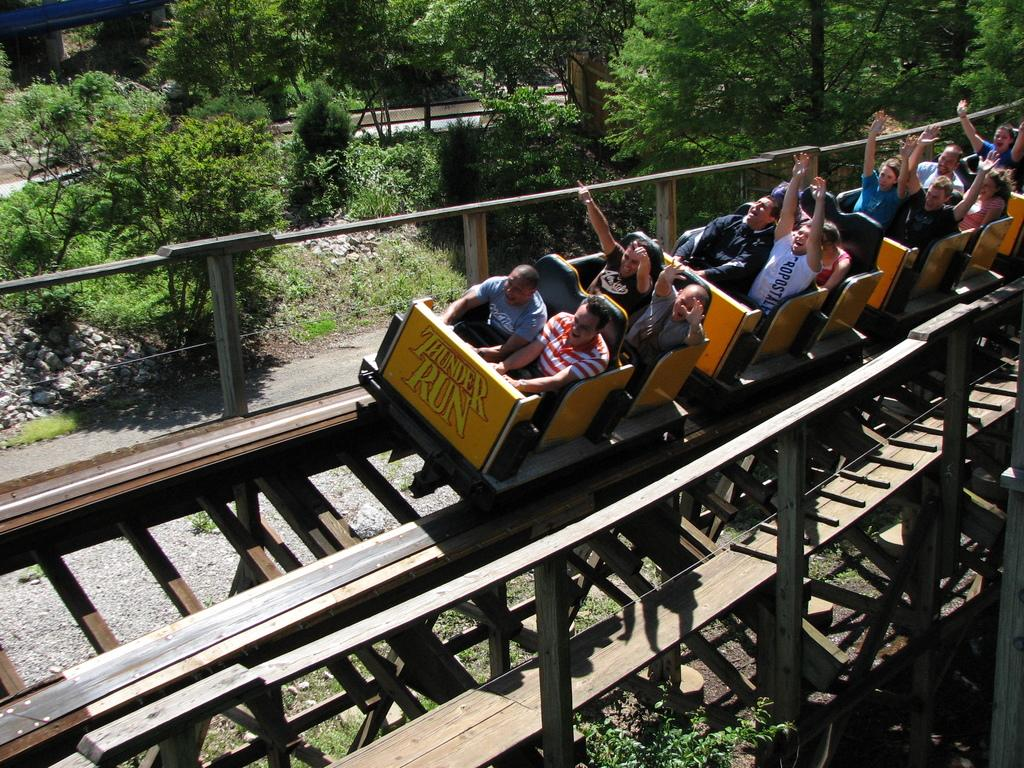<image>
Offer a succinct explanation of the picture presented. an image of a roller coaster called 'THUNDER RUN' with people on it on the tracks. 